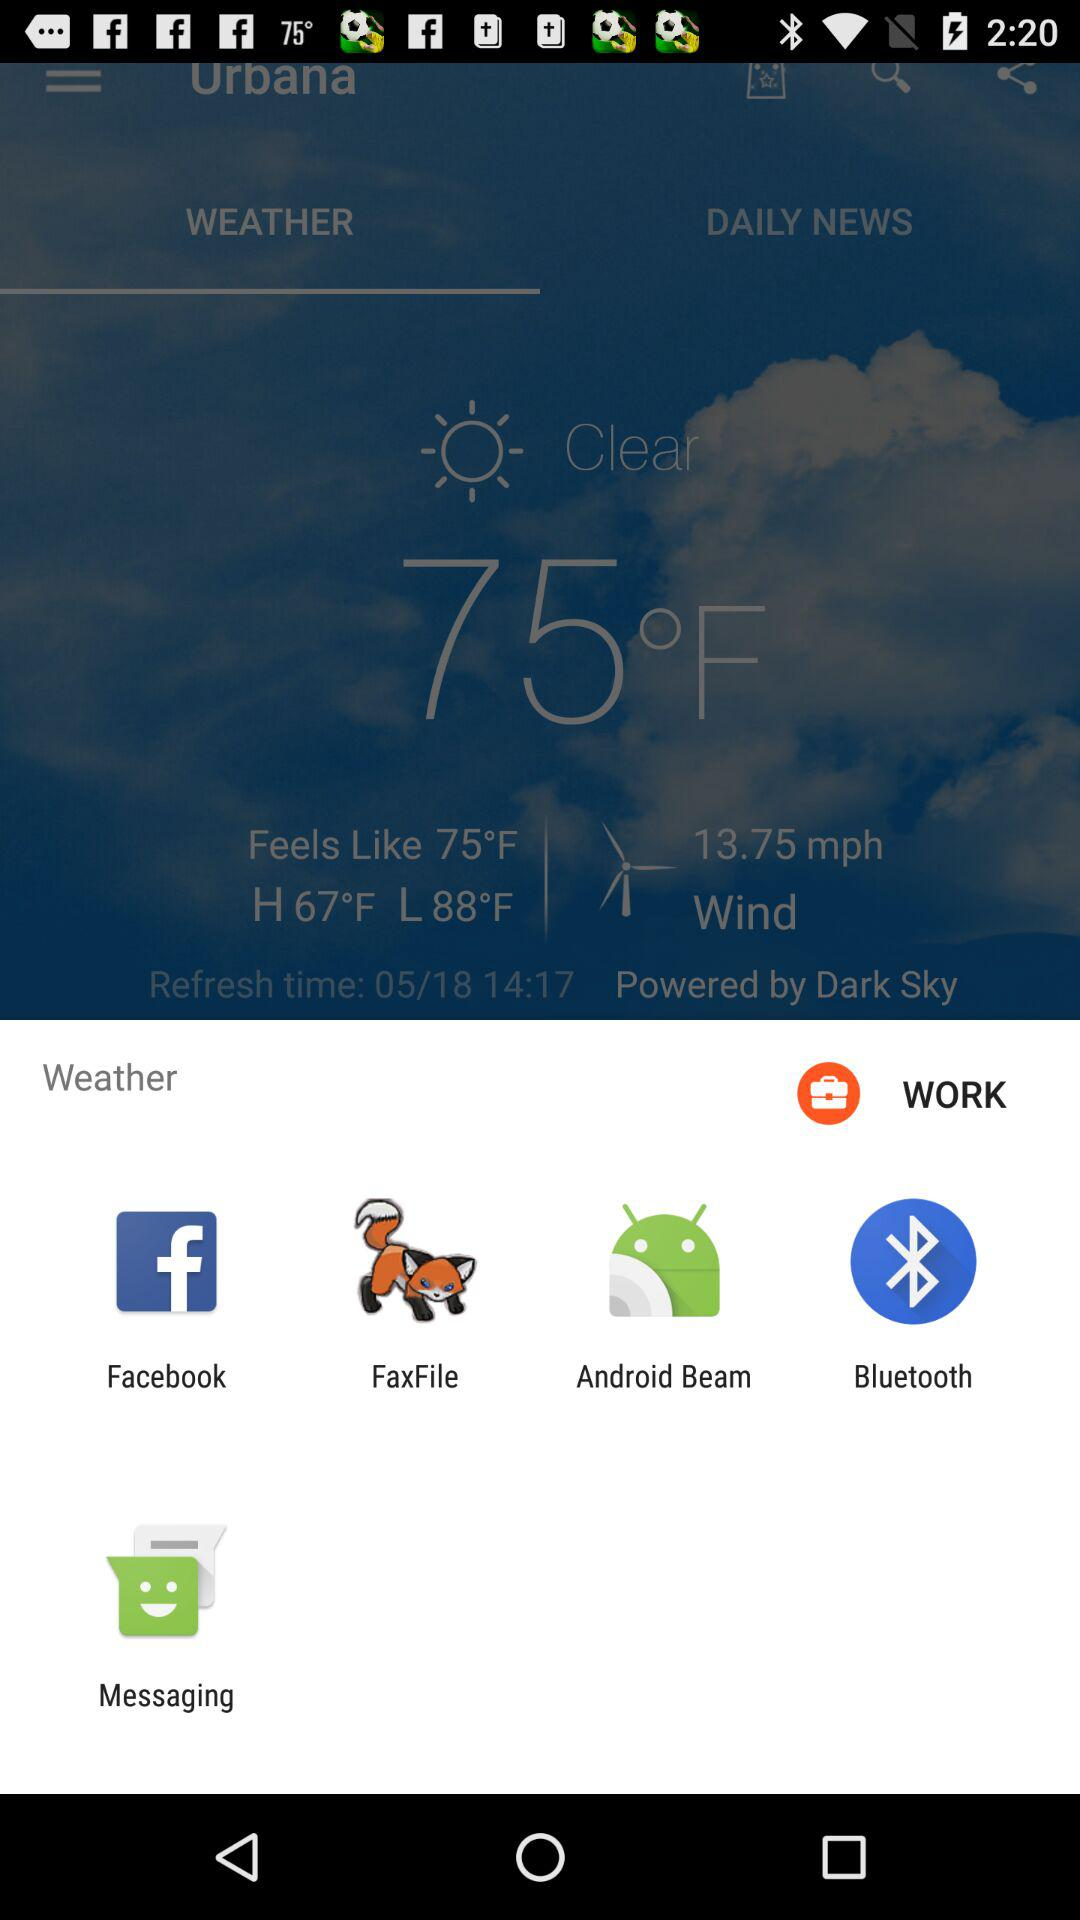What is the lowest temperature? The lowest temperature is 88 °F. 